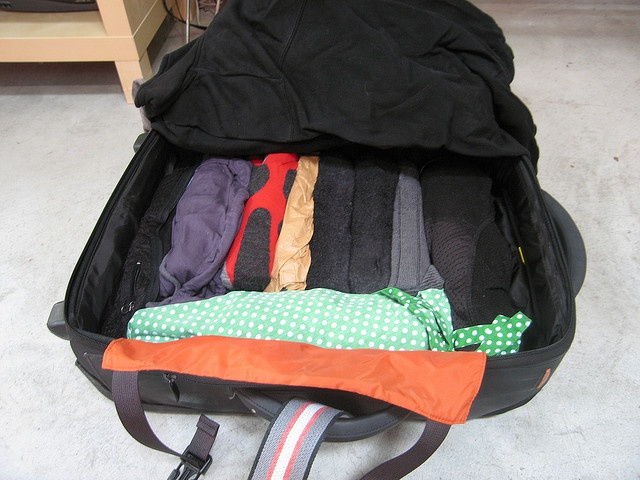Describe the objects in this image and their specific colors. I can see a suitcase in black, gray, and salmon tones in this image. 